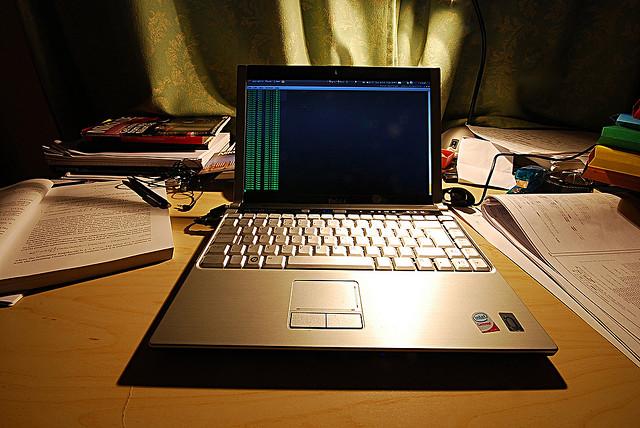Is perspective correct in this photo?
Be succinct. No. Is there an open book?
Write a very short answer. Yes. Is this a desktop or laptop?
Short answer required. Laptop. 